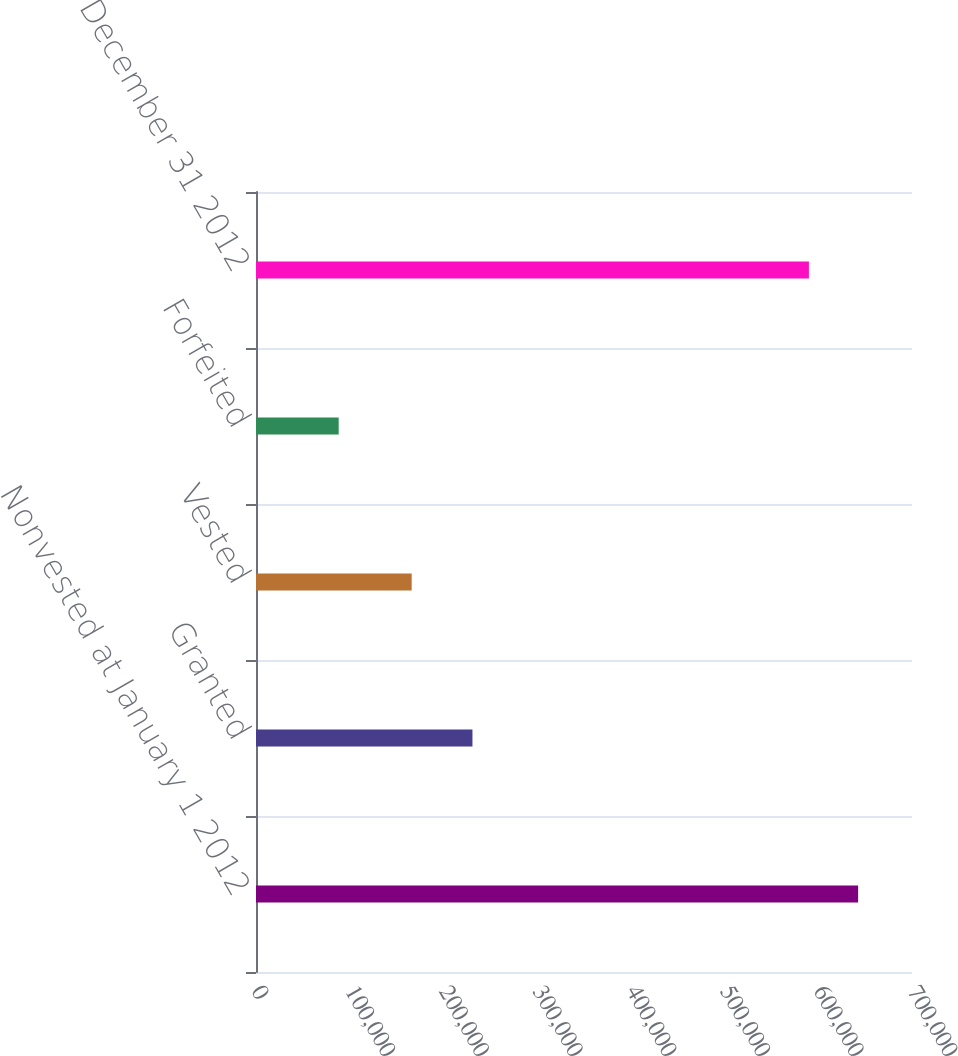Convert chart. <chart><loc_0><loc_0><loc_500><loc_500><bar_chart><fcel>Nonvested at January 1 2012<fcel>Granted<fcel>Vested<fcel>Forfeited<fcel>Nonvested at December 31 2012<nl><fcel>642500<fcel>230975<fcel>166134<fcel>88230<fcel>589986<nl></chart> 